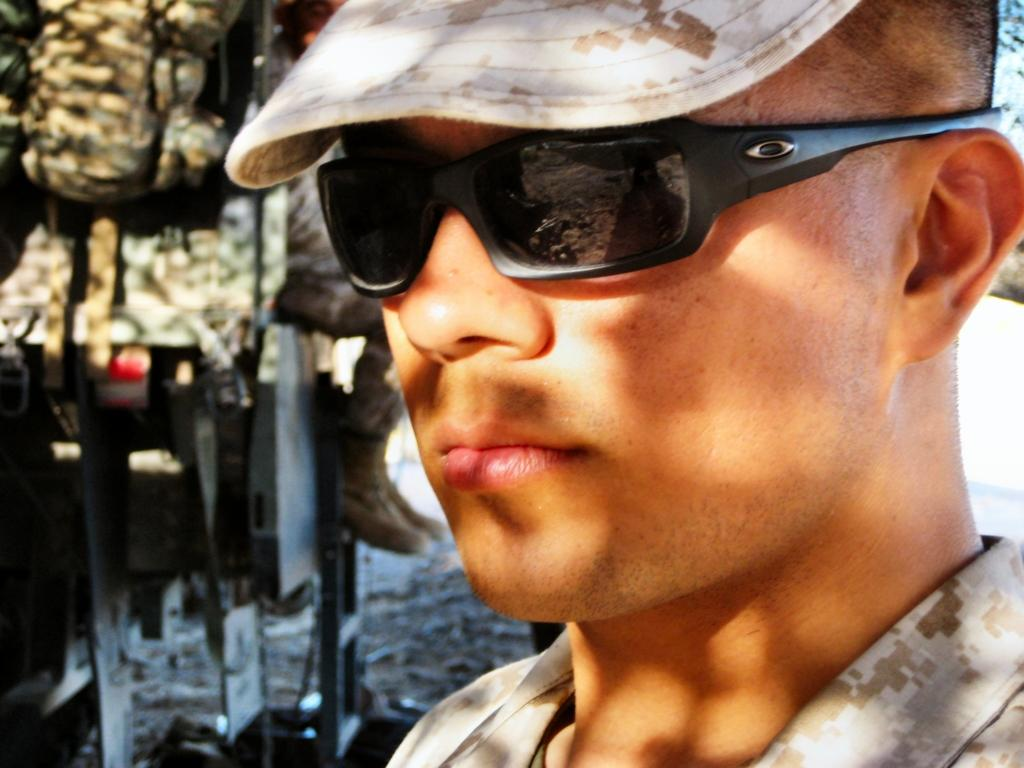Who or what is present in the image? There is a person in the image. What is the person wearing on their head? The person is wearing a cap. What type of eyewear is the person wearing? The person is wearing goggles. What type of cable is the person holding in the image? There is no cable present in the image. What is the person's dental condition in the image? The image does not provide any information about the person's teeth or dental condition. 